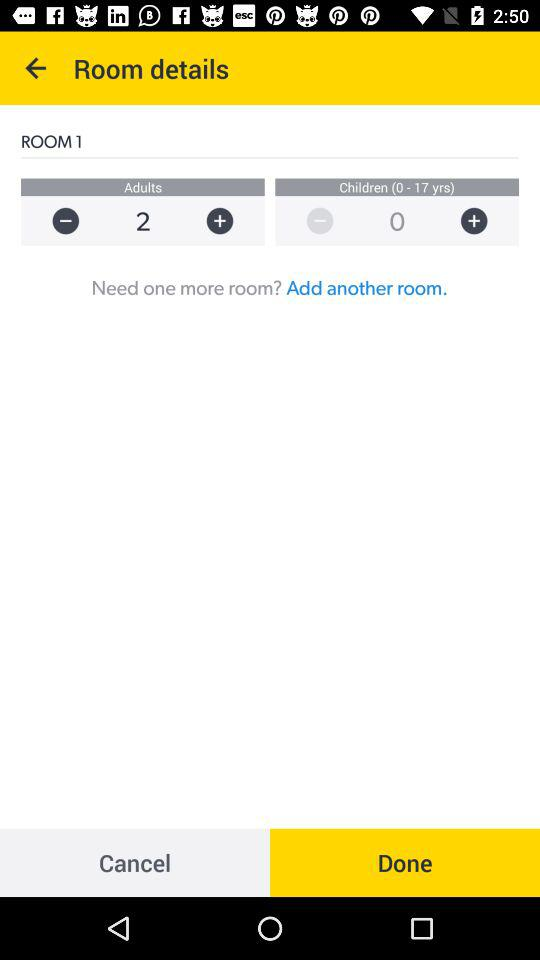What is the name of the room? The name of the room is "ROOM 1". 